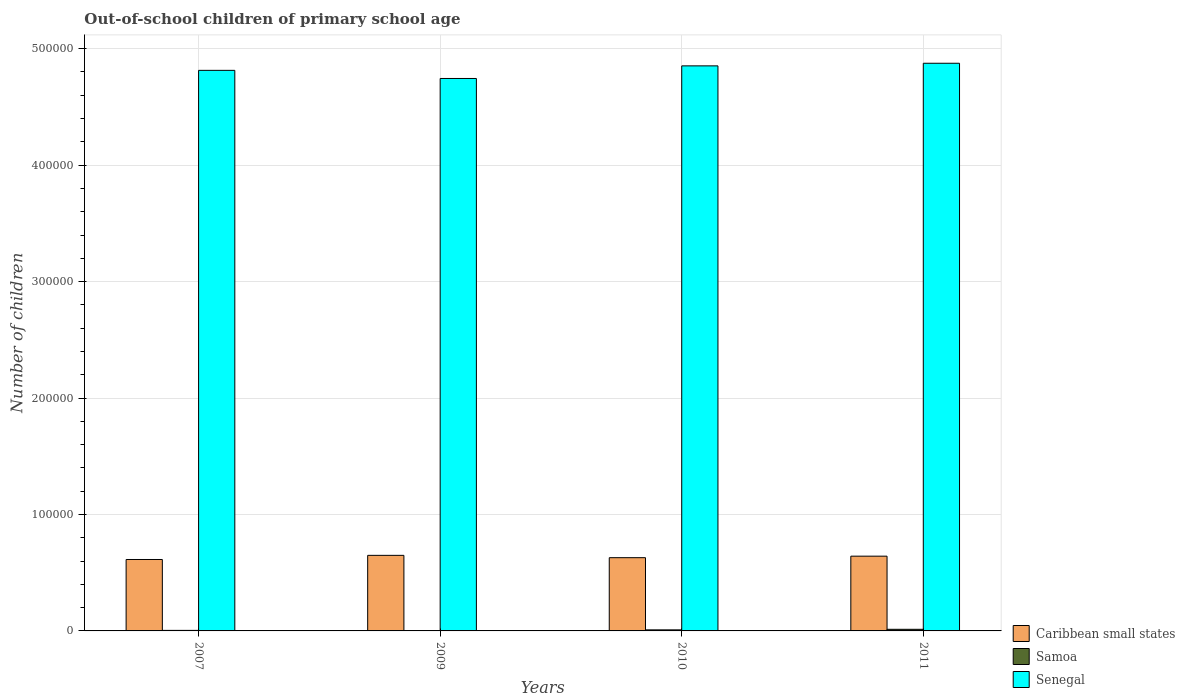How many groups of bars are there?
Your answer should be very brief. 4. Are the number of bars per tick equal to the number of legend labels?
Make the answer very short. Yes. How many bars are there on the 2nd tick from the left?
Offer a very short reply. 3. How many bars are there on the 3rd tick from the right?
Your response must be concise. 3. What is the label of the 2nd group of bars from the left?
Make the answer very short. 2009. In how many cases, is the number of bars for a given year not equal to the number of legend labels?
Offer a very short reply. 0. What is the number of out-of-school children in Senegal in 2007?
Provide a succinct answer. 4.81e+05. Across all years, what is the maximum number of out-of-school children in Senegal?
Offer a very short reply. 4.87e+05. In which year was the number of out-of-school children in Senegal maximum?
Provide a succinct answer. 2011. What is the total number of out-of-school children in Samoa in the graph?
Keep it short and to the point. 2822. What is the difference between the number of out-of-school children in Senegal in 2007 and that in 2009?
Provide a short and direct response. 6987. What is the difference between the number of out-of-school children in Senegal in 2010 and the number of out-of-school children in Caribbean small states in 2009?
Your response must be concise. 4.20e+05. What is the average number of out-of-school children in Caribbean small states per year?
Your answer should be compact. 6.33e+04. In the year 2009, what is the difference between the number of out-of-school children in Caribbean small states and number of out-of-school children in Samoa?
Ensure brevity in your answer.  6.48e+04. What is the ratio of the number of out-of-school children in Samoa in 2007 to that in 2011?
Your answer should be compact. 0.33. Is the number of out-of-school children in Caribbean small states in 2007 less than that in 2011?
Offer a terse response. Yes. Is the difference between the number of out-of-school children in Caribbean small states in 2009 and 2011 greater than the difference between the number of out-of-school children in Samoa in 2009 and 2011?
Your answer should be very brief. Yes. What is the difference between the highest and the second highest number of out-of-school children in Senegal?
Your answer should be very brief. 2239. What is the difference between the highest and the lowest number of out-of-school children in Senegal?
Make the answer very short. 1.31e+04. In how many years, is the number of out-of-school children in Caribbean small states greater than the average number of out-of-school children in Caribbean small states taken over all years?
Give a very brief answer. 2. What does the 1st bar from the left in 2011 represents?
Give a very brief answer. Caribbean small states. What does the 2nd bar from the right in 2009 represents?
Make the answer very short. Samoa. How many years are there in the graph?
Your answer should be very brief. 4. What is the difference between two consecutive major ticks on the Y-axis?
Offer a very short reply. 1.00e+05. Are the values on the major ticks of Y-axis written in scientific E-notation?
Offer a very short reply. No. Does the graph contain any zero values?
Your answer should be compact. No. Where does the legend appear in the graph?
Provide a succinct answer. Bottom right. How many legend labels are there?
Keep it short and to the point. 3. What is the title of the graph?
Offer a very short reply. Out-of-school children of primary school age. Does "Bosnia and Herzegovina" appear as one of the legend labels in the graph?
Your response must be concise. No. What is the label or title of the Y-axis?
Make the answer very short. Number of children. What is the Number of children in Caribbean small states in 2007?
Provide a short and direct response. 6.13e+04. What is the Number of children in Samoa in 2007?
Provide a succinct answer. 456. What is the Number of children of Senegal in 2007?
Provide a short and direct response. 4.81e+05. What is the Number of children in Caribbean small states in 2009?
Offer a terse response. 6.49e+04. What is the Number of children in Senegal in 2009?
Give a very brief answer. 4.74e+05. What is the Number of children in Caribbean small states in 2010?
Your response must be concise. 6.29e+04. What is the Number of children of Samoa in 2010?
Offer a very short reply. 902. What is the Number of children in Senegal in 2010?
Your response must be concise. 4.85e+05. What is the Number of children in Caribbean small states in 2011?
Provide a succinct answer. 6.42e+04. What is the Number of children in Samoa in 2011?
Provide a short and direct response. 1391. What is the Number of children of Senegal in 2011?
Your answer should be very brief. 4.87e+05. Across all years, what is the maximum Number of children in Caribbean small states?
Provide a short and direct response. 6.49e+04. Across all years, what is the maximum Number of children in Samoa?
Give a very brief answer. 1391. Across all years, what is the maximum Number of children of Senegal?
Offer a very short reply. 4.87e+05. Across all years, what is the minimum Number of children in Caribbean small states?
Your response must be concise. 6.13e+04. Across all years, what is the minimum Number of children in Samoa?
Provide a short and direct response. 73. Across all years, what is the minimum Number of children of Senegal?
Your response must be concise. 4.74e+05. What is the total Number of children in Caribbean small states in the graph?
Keep it short and to the point. 2.53e+05. What is the total Number of children in Samoa in the graph?
Your answer should be compact. 2822. What is the total Number of children in Senegal in the graph?
Your answer should be very brief. 1.93e+06. What is the difference between the Number of children in Caribbean small states in 2007 and that in 2009?
Provide a succinct answer. -3556. What is the difference between the Number of children of Samoa in 2007 and that in 2009?
Provide a short and direct response. 383. What is the difference between the Number of children in Senegal in 2007 and that in 2009?
Your answer should be very brief. 6987. What is the difference between the Number of children in Caribbean small states in 2007 and that in 2010?
Your answer should be very brief. -1553. What is the difference between the Number of children of Samoa in 2007 and that in 2010?
Keep it short and to the point. -446. What is the difference between the Number of children of Senegal in 2007 and that in 2010?
Make the answer very short. -3849. What is the difference between the Number of children in Caribbean small states in 2007 and that in 2011?
Offer a terse response. -2865. What is the difference between the Number of children in Samoa in 2007 and that in 2011?
Your response must be concise. -935. What is the difference between the Number of children in Senegal in 2007 and that in 2011?
Your response must be concise. -6088. What is the difference between the Number of children in Caribbean small states in 2009 and that in 2010?
Ensure brevity in your answer.  2003. What is the difference between the Number of children of Samoa in 2009 and that in 2010?
Keep it short and to the point. -829. What is the difference between the Number of children of Senegal in 2009 and that in 2010?
Your answer should be compact. -1.08e+04. What is the difference between the Number of children in Caribbean small states in 2009 and that in 2011?
Make the answer very short. 691. What is the difference between the Number of children in Samoa in 2009 and that in 2011?
Offer a very short reply. -1318. What is the difference between the Number of children of Senegal in 2009 and that in 2011?
Give a very brief answer. -1.31e+04. What is the difference between the Number of children of Caribbean small states in 2010 and that in 2011?
Your response must be concise. -1312. What is the difference between the Number of children in Samoa in 2010 and that in 2011?
Your answer should be compact. -489. What is the difference between the Number of children in Senegal in 2010 and that in 2011?
Ensure brevity in your answer.  -2239. What is the difference between the Number of children in Caribbean small states in 2007 and the Number of children in Samoa in 2009?
Provide a short and direct response. 6.13e+04. What is the difference between the Number of children in Caribbean small states in 2007 and the Number of children in Senegal in 2009?
Ensure brevity in your answer.  -4.13e+05. What is the difference between the Number of children in Samoa in 2007 and the Number of children in Senegal in 2009?
Provide a short and direct response. -4.74e+05. What is the difference between the Number of children of Caribbean small states in 2007 and the Number of children of Samoa in 2010?
Your response must be concise. 6.04e+04. What is the difference between the Number of children in Caribbean small states in 2007 and the Number of children in Senegal in 2010?
Offer a terse response. -4.24e+05. What is the difference between the Number of children in Samoa in 2007 and the Number of children in Senegal in 2010?
Provide a succinct answer. -4.85e+05. What is the difference between the Number of children in Caribbean small states in 2007 and the Number of children in Samoa in 2011?
Ensure brevity in your answer.  5.99e+04. What is the difference between the Number of children in Caribbean small states in 2007 and the Number of children in Senegal in 2011?
Your response must be concise. -4.26e+05. What is the difference between the Number of children in Samoa in 2007 and the Number of children in Senegal in 2011?
Provide a short and direct response. -4.87e+05. What is the difference between the Number of children of Caribbean small states in 2009 and the Number of children of Samoa in 2010?
Provide a short and direct response. 6.40e+04. What is the difference between the Number of children in Caribbean small states in 2009 and the Number of children in Senegal in 2010?
Offer a terse response. -4.20e+05. What is the difference between the Number of children in Samoa in 2009 and the Number of children in Senegal in 2010?
Offer a very short reply. -4.85e+05. What is the difference between the Number of children of Caribbean small states in 2009 and the Number of children of Samoa in 2011?
Your response must be concise. 6.35e+04. What is the difference between the Number of children of Caribbean small states in 2009 and the Number of children of Senegal in 2011?
Ensure brevity in your answer.  -4.23e+05. What is the difference between the Number of children of Samoa in 2009 and the Number of children of Senegal in 2011?
Keep it short and to the point. -4.87e+05. What is the difference between the Number of children in Caribbean small states in 2010 and the Number of children in Samoa in 2011?
Provide a short and direct response. 6.15e+04. What is the difference between the Number of children in Caribbean small states in 2010 and the Number of children in Senegal in 2011?
Ensure brevity in your answer.  -4.25e+05. What is the difference between the Number of children in Samoa in 2010 and the Number of children in Senegal in 2011?
Offer a terse response. -4.87e+05. What is the average Number of children of Caribbean small states per year?
Offer a terse response. 6.33e+04. What is the average Number of children in Samoa per year?
Offer a very short reply. 705.5. What is the average Number of children of Senegal per year?
Your answer should be compact. 4.82e+05. In the year 2007, what is the difference between the Number of children in Caribbean small states and Number of children in Samoa?
Offer a terse response. 6.09e+04. In the year 2007, what is the difference between the Number of children in Caribbean small states and Number of children in Senegal?
Offer a very short reply. -4.20e+05. In the year 2007, what is the difference between the Number of children in Samoa and Number of children in Senegal?
Make the answer very short. -4.81e+05. In the year 2009, what is the difference between the Number of children in Caribbean small states and Number of children in Samoa?
Your answer should be very brief. 6.48e+04. In the year 2009, what is the difference between the Number of children in Caribbean small states and Number of children in Senegal?
Offer a very short reply. -4.10e+05. In the year 2009, what is the difference between the Number of children in Samoa and Number of children in Senegal?
Keep it short and to the point. -4.74e+05. In the year 2010, what is the difference between the Number of children in Caribbean small states and Number of children in Samoa?
Your response must be concise. 6.20e+04. In the year 2010, what is the difference between the Number of children of Caribbean small states and Number of children of Senegal?
Keep it short and to the point. -4.22e+05. In the year 2010, what is the difference between the Number of children of Samoa and Number of children of Senegal?
Keep it short and to the point. -4.84e+05. In the year 2011, what is the difference between the Number of children in Caribbean small states and Number of children in Samoa?
Provide a short and direct response. 6.28e+04. In the year 2011, what is the difference between the Number of children of Caribbean small states and Number of children of Senegal?
Ensure brevity in your answer.  -4.23e+05. In the year 2011, what is the difference between the Number of children in Samoa and Number of children in Senegal?
Your answer should be very brief. -4.86e+05. What is the ratio of the Number of children in Caribbean small states in 2007 to that in 2009?
Ensure brevity in your answer.  0.95. What is the ratio of the Number of children of Samoa in 2007 to that in 2009?
Give a very brief answer. 6.25. What is the ratio of the Number of children of Senegal in 2007 to that in 2009?
Provide a short and direct response. 1.01. What is the ratio of the Number of children in Caribbean small states in 2007 to that in 2010?
Ensure brevity in your answer.  0.98. What is the ratio of the Number of children of Samoa in 2007 to that in 2010?
Provide a short and direct response. 0.51. What is the ratio of the Number of children of Caribbean small states in 2007 to that in 2011?
Keep it short and to the point. 0.96. What is the ratio of the Number of children of Samoa in 2007 to that in 2011?
Make the answer very short. 0.33. What is the ratio of the Number of children in Senegal in 2007 to that in 2011?
Your answer should be very brief. 0.99. What is the ratio of the Number of children in Caribbean small states in 2009 to that in 2010?
Offer a very short reply. 1.03. What is the ratio of the Number of children in Samoa in 2009 to that in 2010?
Make the answer very short. 0.08. What is the ratio of the Number of children in Senegal in 2009 to that in 2010?
Provide a succinct answer. 0.98. What is the ratio of the Number of children of Caribbean small states in 2009 to that in 2011?
Offer a terse response. 1.01. What is the ratio of the Number of children of Samoa in 2009 to that in 2011?
Offer a very short reply. 0.05. What is the ratio of the Number of children in Senegal in 2009 to that in 2011?
Your answer should be compact. 0.97. What is the ratio of the Number of children in Caribbean small states in 2010 to that in 2011?
Offer a terse response. 0.98. What is the ratio of the Number of children of Samoa in 2010 to that in 2011?
Give a very brief answer. 0.65. What is the ratio of the Number of children of Senegal in 2010 to that in 2011?
Your answer should be compact. 1. What is the difference between the highest and the second highest Number of children of Caribbean small states?
Ensure brevity in your answer.  691. What is the difference between the highest and the second highest Number of children in Samoa?
Your answer should be compact. 489. What is the difference between the highest and the second highest Number of children in Senegal?
Ensure brevity in your answer.  2239. What is the difference between the highest and the lowest Number of children of Caribbean small states?
Your response must be concise. 3556. What is the difference between the highest and the lowest Number of children in Samoa?
Your answer should be very brief. 1318. What is the difference between the highest and the lowest Number of children in Senegal?
Offer a terse response. 1.31e+04. 